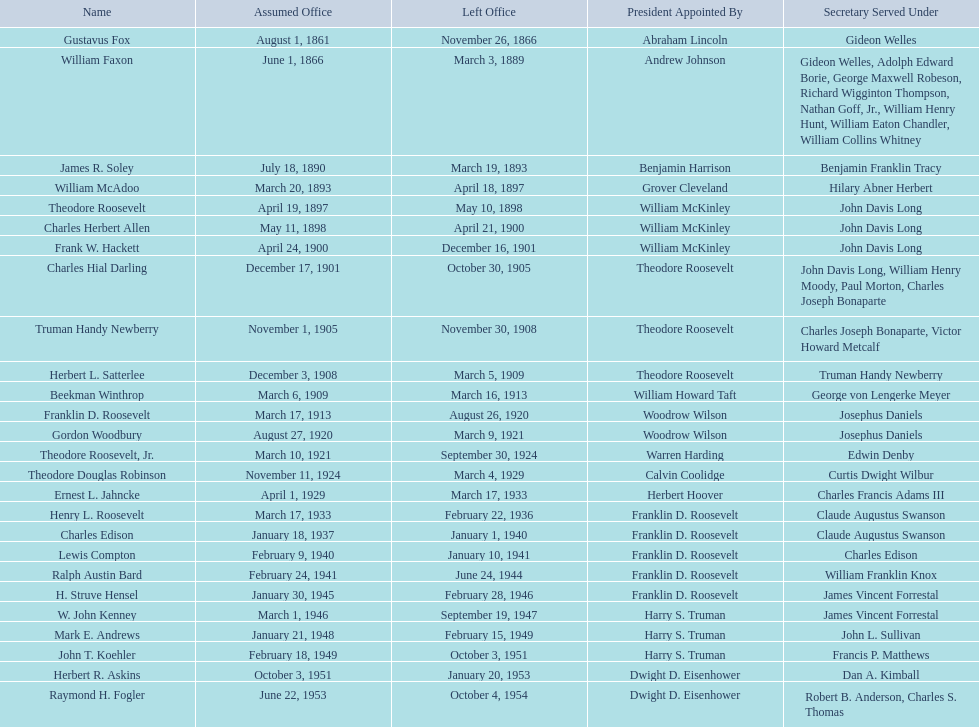Who were the individuals that held the position of assistant secretary of the navy during the 1900s? Charles Herbert Allen, Frank W. Hackett, Charles Hial Darling, Truman Handy Newberry, Herbert L. Satterlee, Beekman Winthrop, Franklin D. Roosevelt, Gordon Woodbury, Theodore Roosevelt, Jr., Theodore Douglas Robinson, Ernest L. Jahncke, Henry L. Roosevelt, Charles Edison, Lewis Compton, Ralph Austin Bard, H. Struve Hensel, W. John Kenney, Mark E. Andrews, John T. Koehler, Herbert R. Askins, Raymond H. Fogler. On what date was raymond h. fogler appointed to this position? June 22, 1953. When did raymond h. fogler's term as assistant secretary of the navy end? October 4, 1954. 